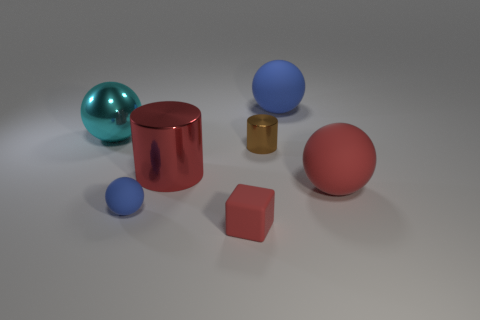What number of red shiny objects are the same size as the red rubber cube?
Keep it short and to the point. 0. There is a large matte object behind the large cyan metallic thing; is there a brown cylinder on the right side of it?
Ensure brevity in your answer.  No. What number of yellow objects are big spheres or tiny blocks?
Provide a succinct answer. 0. The big shiny cylinder is what color?
Keep it short and to the point. Red. There is a cube that is the same material as the tiny blue sphere; what is its size?
Give a very brief answer. Small. What number of other objects have the same shape as the large cyan object?
Offer a very short reply. 3. There is a shiny thing that is to the left of the blue rubber thing that is on the left side of the large blue rubber object; what is its size?
Ensure brevity in your answer.  Large. There is a cyan sphere that is the same size as the red metal cylinder; what material is it?
Make the answer very short. Metal. Is there a brown object made of the same material as the large blue sphere?
Your response must be concise. No. What color is the big rubber object that is behind the big red thing on the right side of the big rubber thing behind the red cylinder?
Offer a very short reply. Blue. 